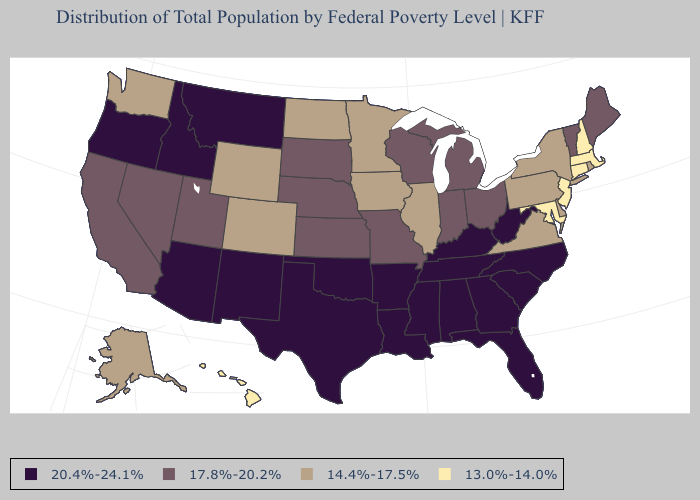What is the highest value in states that border Tennessee?
Short answer required. 20.4%-24.1%. Does the map have missing data?
Quick response, please. No. Among the states that border Missouri , does Illinois have the lowest value?
Give a very brief answer. Yes. Name the states that have a value in the range 17.8%-20.2%?
Answer briefly. California, Indiana, Kansas, Maine, Michigan, Missouri, Nebraska, Nevada, Ohio, South Dakota, Utah, Vermont, Wisconsin. Does Utah have a higher value than Maryland?
Quick response, please. Yes. What is the value of Nevada?
Answer briefly. 17.8%-20.2%. Name the states that have a value in the range 17.8%-20.2%?
Give a very brief answer. California, Indiana, Kansas, Maine, Michigan, Missouri, Nebraska, Nevada, Ohio, South Dakota, Utah, Vermont, Wisconsin. Which states have the lowest value in the South?
Be succinct. Maryland. What is the highest value in states that border Massachusetts?
Short answer required. 17.8%-20.2%. What is the value of New Mexico?
Concise answer only. 20.4%-24.1%. Name the states that have a value in the range 17.8%-20.2%?
Quick response, please. California, Indiana, Kansas, Maine, Michigan, Missouri, Nebraska, Nevada, Ohio, South Dakota, Utah, Vermont, Wisconsin. How many symbols are there in the legend?
Be succinct. 4. Does the map have missing data?
Quick response, please. No. Which states have the highest value in the USA?
Short answer required. Alabama, Arizona, Arkansas, Florida, Georgia, Idaho, Kentucky, Louisiana, Mississippi, Montana, New Mexico, North Carolina, Oklahoma, Oregon, South Carolina, Tennessee, Texas, West Virginia. What is the lowest value in the MidWest?
Write a very short answer. 14.4%-17.5%. 